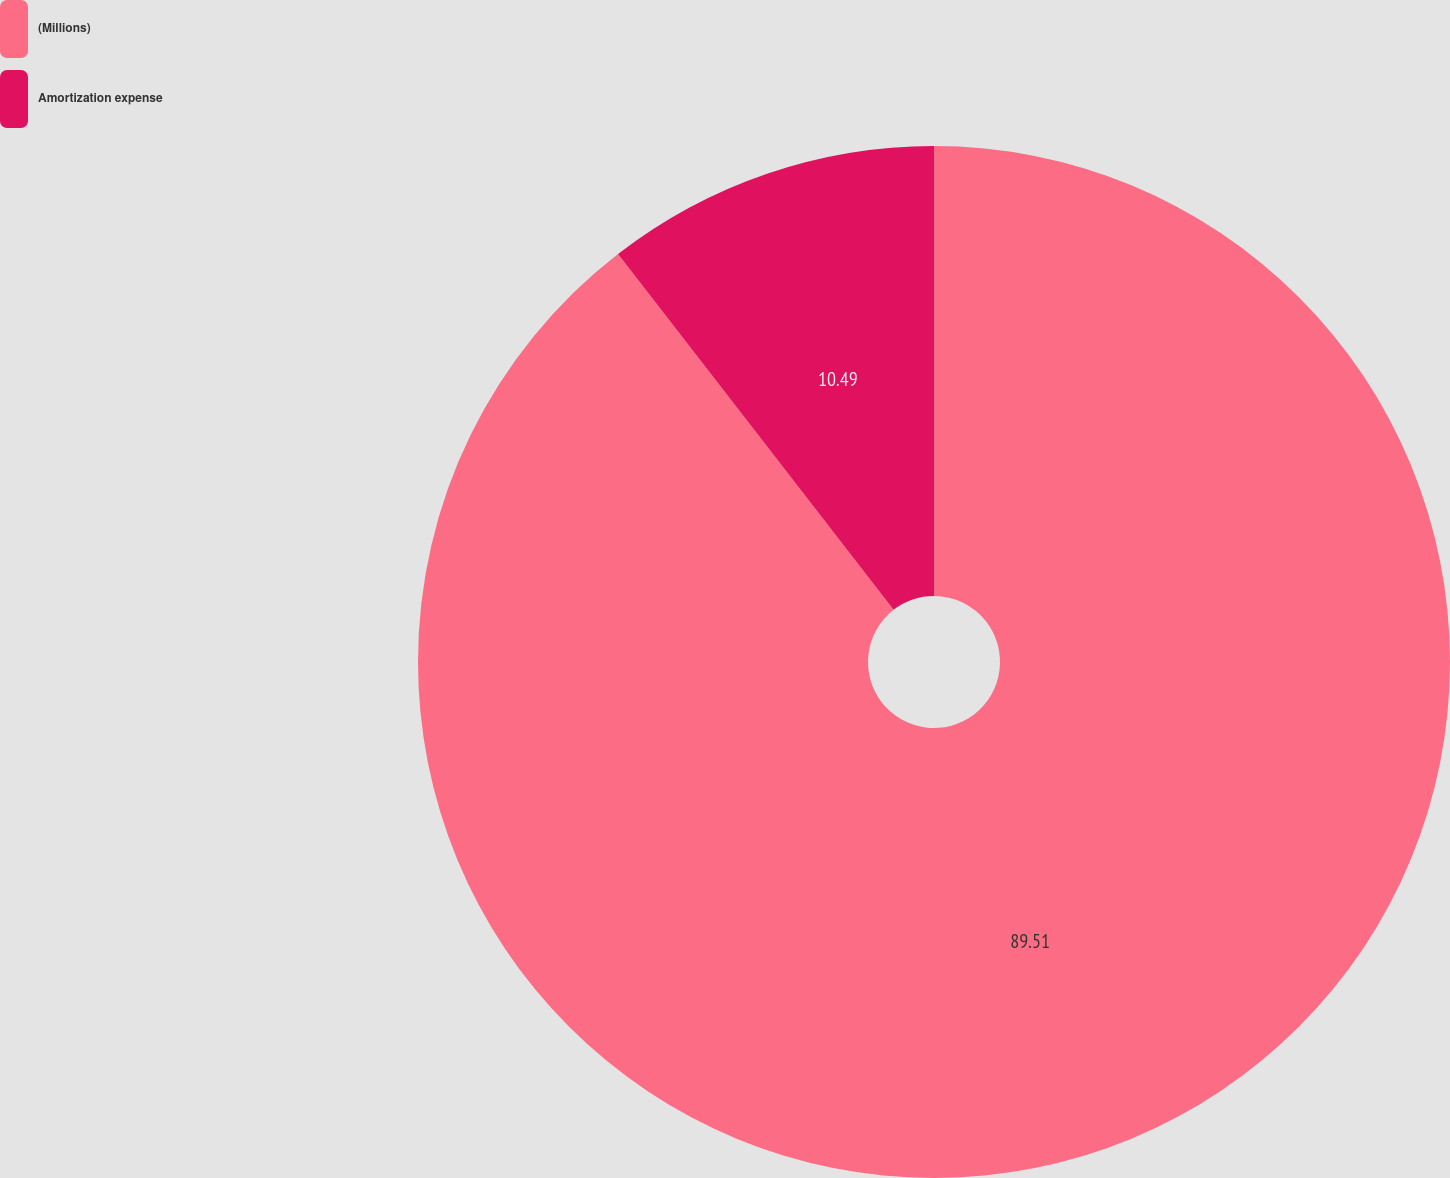Convert chart to OTSL. <chart><loc_0><loc_0><loc_500><loc_500><pie_chart><fcel>(Millions)<fcel>Amortization expense<nl><fcel>89.51%<fcel>10.49%<nl></chart> 